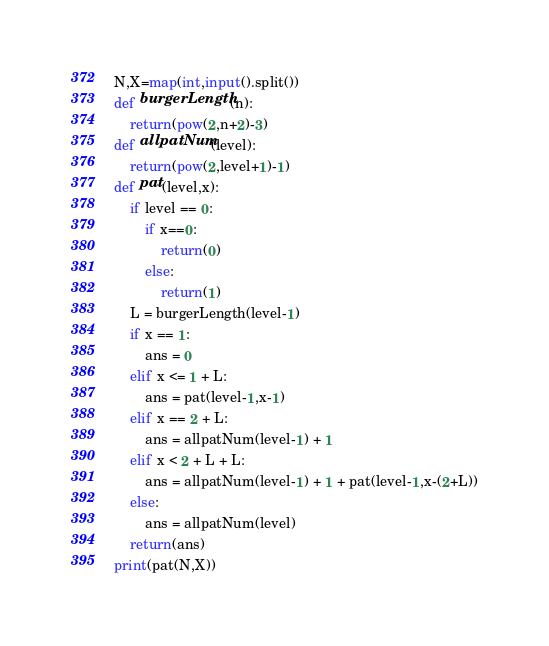<code> <loc_0><loc_0><loc_500><loc_500><_Python_>N,X=map(int,input().split())
def burgerLength(n):
    return(pow(2,n+2)-3)
def allpatNum(level):
    return(pow(2,level+1)-1)
def pat(level,x):
    if level == 0:
        if x==0:
            return(0)
        else:
            return(1)
    L = burgerLength(level-1)
    if x == 1:
        ans = 0
    elif x <= 1 + L:
        ans = pat(level-1,x-1)
    elif x == 2 + L:
        ans = allpatNum(level-1) + 1
    elif x < 2 + L + L:
        ans = allpatNum(level-1) + 1 + pat(level-1,x-(2+L))
    else:
        ans = allpatNum(level)
    return(ans)
print(pat(N,X))</code> 